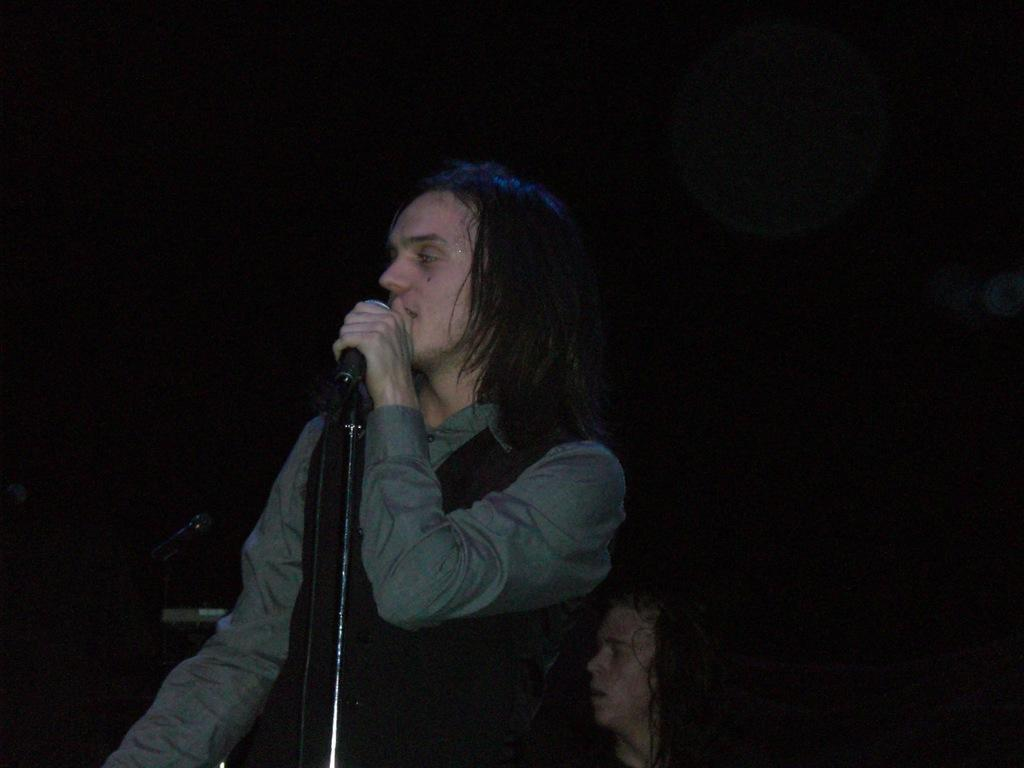What is the man in the foreground of the image doing? The man is standing in the foreground of the image and holding a mic. Where is the mic positioned in relation to the man? The mic is in front of the man. Can you describe the other person in the image? There is another man in the background of the image. How would you describe the lighting in the image? The background is dark. How many beans are visible on the man's shirt in the image? There are no beans visible on the man's shirt in the image. What type of washing machine is used to clean the man's shirt in the image? There is no washing machine present in the image, and the man's shirt is not being washed. 